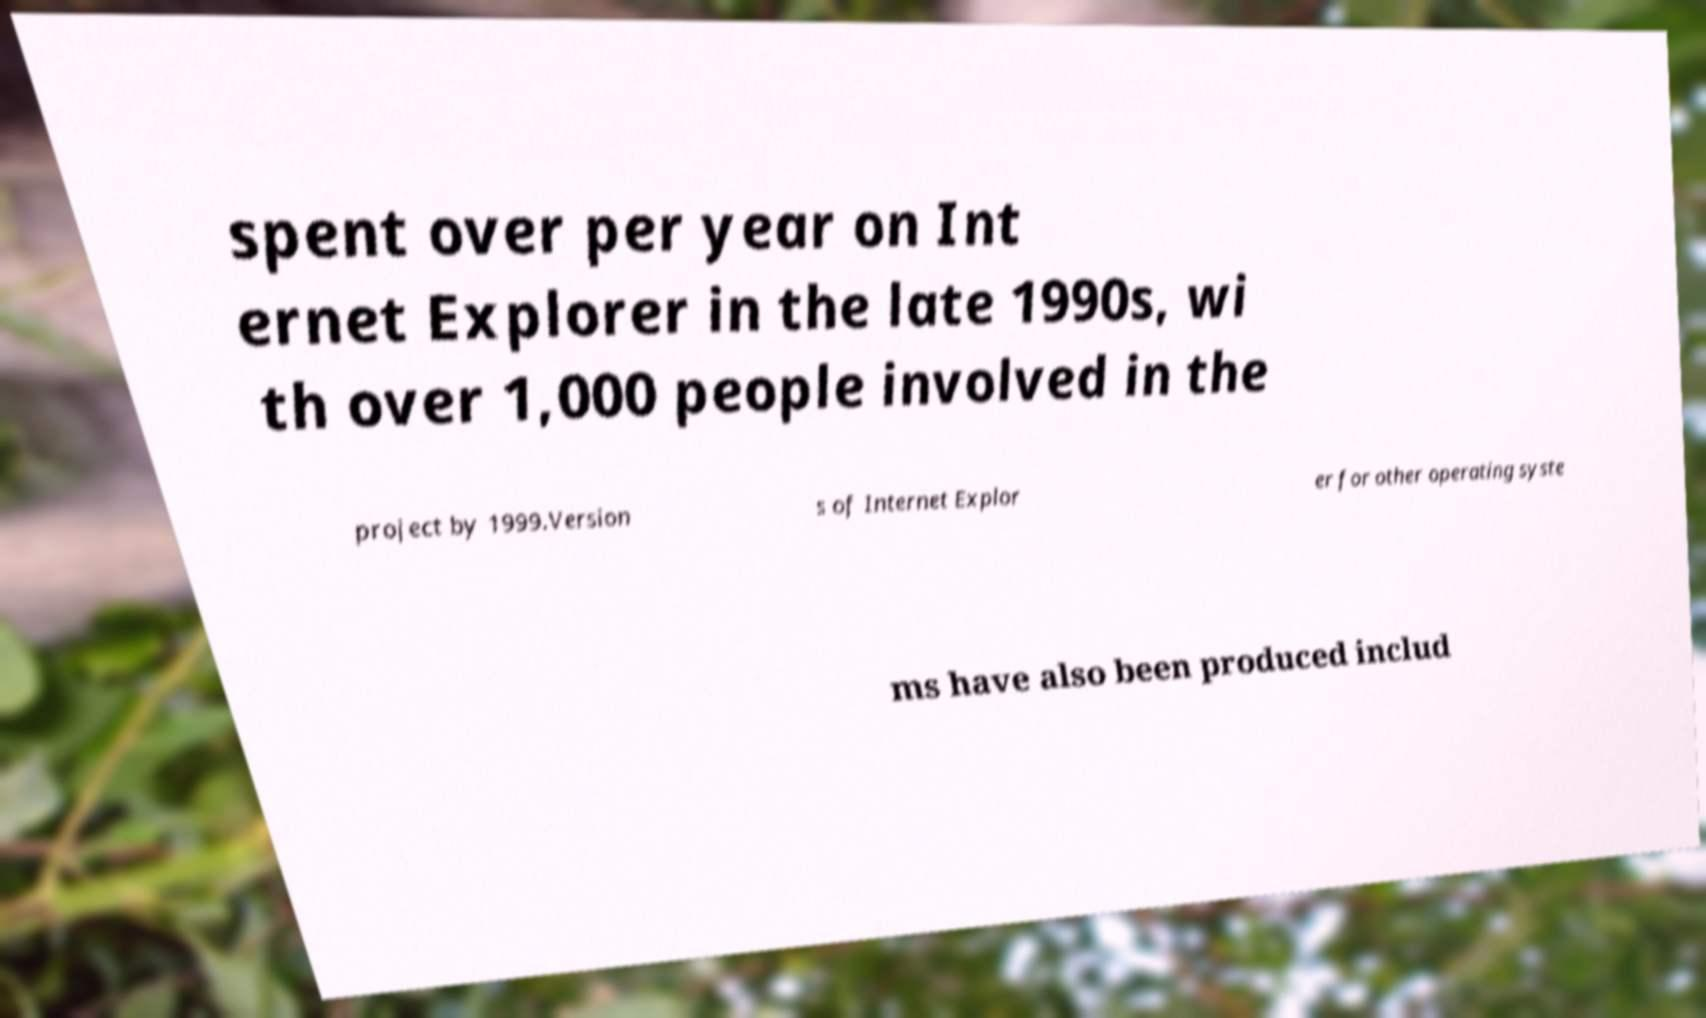Please identify and transcribe the text found in this image. spent over per year on Int ernet Explorer in the late 1990s, wi th over 1,000 people involved in the project by 1999.Version s of Internet Explor er for other operating syste ms have also been produced includ 